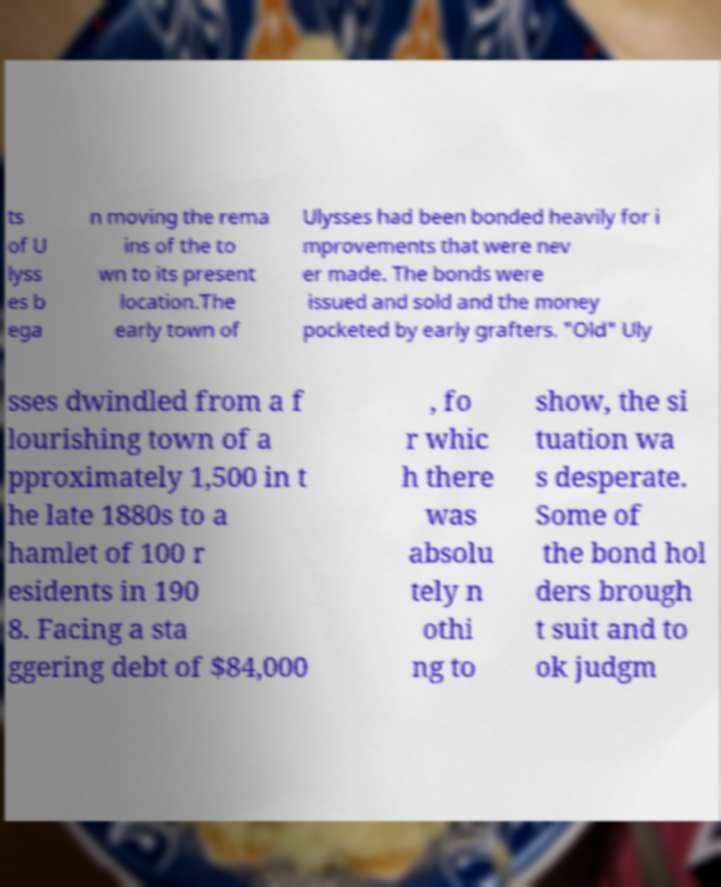Can you read and provide the text displayed in the image?This photo seems to have some interesting text. Can you extract and type it out for me? ts of U lyss es b ega n moving the rema ins of the to wn to its present location.The early town of Ulysses had been bonded heavily for i mprovements that were nev er made. The bonds were issued and sold and the money pocketed by early grafters. "Old" Uly sses dwindled from a f lourishing town of a pproximately 1,500 in t he late 1880s to a hamlet of 100 r esidents in 190 8. Facing a sta ggering debt of $84,000 , fo r whic h there was absolu tely n othi ng to show, the si tuation wa s desperate. Some of the bond hol ders brough t suit and to ok judgm 